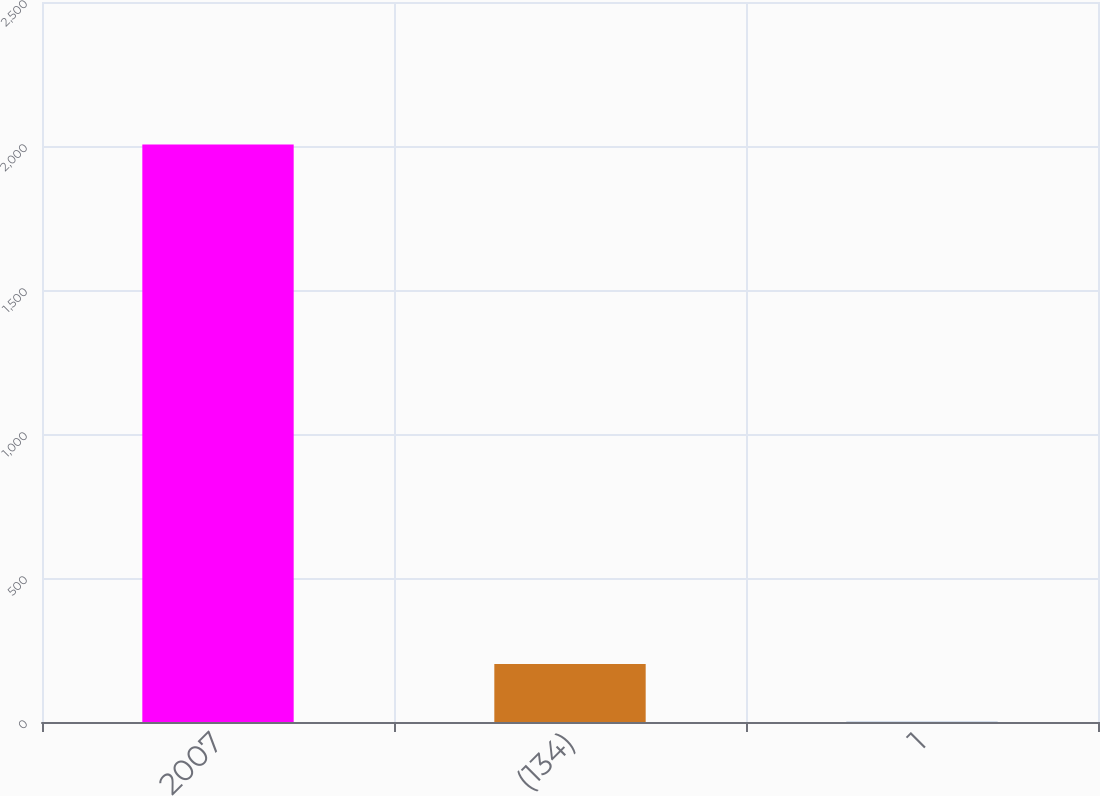Convert chart to OTSL. <chart><loc_0><loc_0><loc_500><loc_500><bar_chart><fcel>2007<fcel>(134)<fcel>1<nl><fcel>2005<fcel>201.4<fcel>1<nl></chart> 